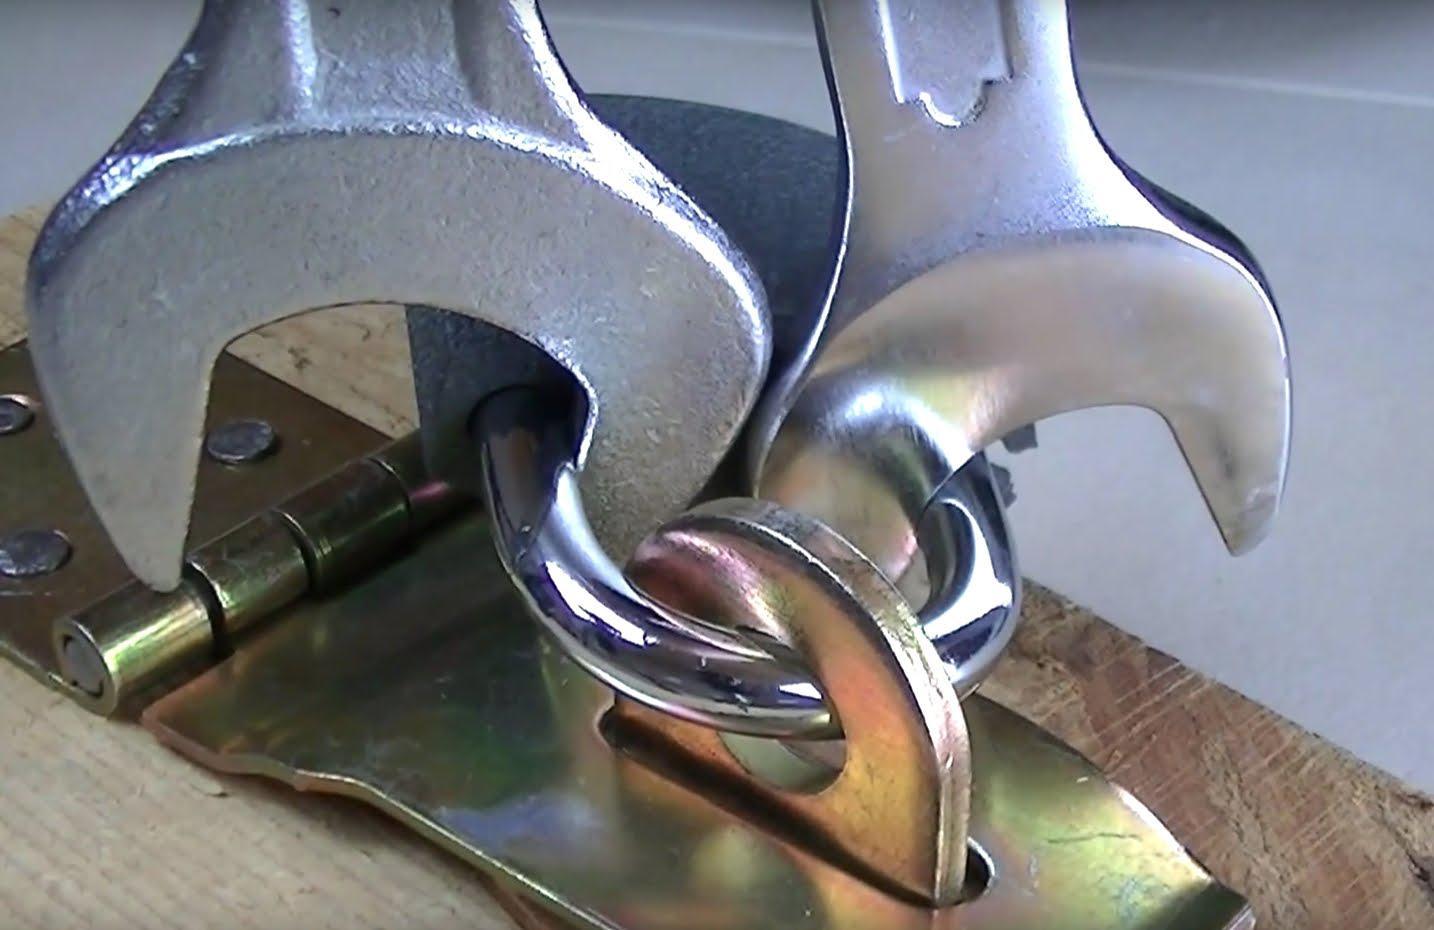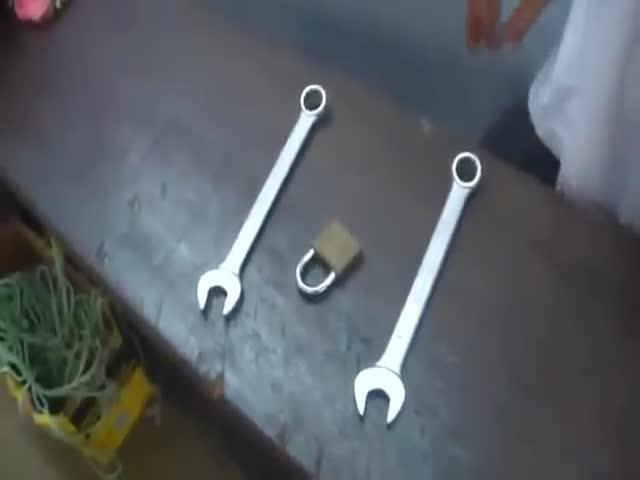The first image is the image on the left, the second image is the image on the right. Examine the images to the left and right. Is the description "Each image contains only non-square vintage locks and contains at least one key." accurate? Answer yes or no. No. The first image is the image on the left, the second image is the image on the right. Evaluate the accuracy of this statement regarding the images: "At least one key is lying beside a lock.". Is it true? Answer yes or no. No. 